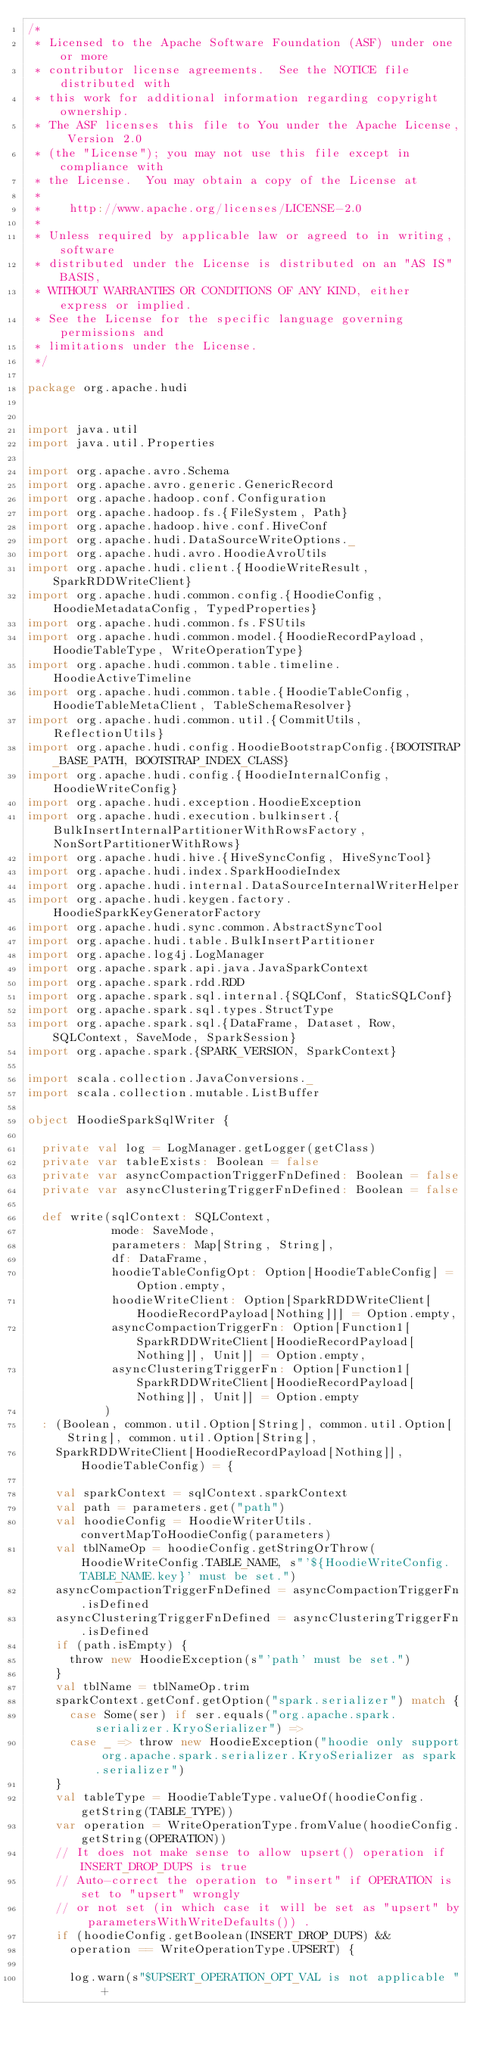<code> <loc_0><loc_0><loc_500><loc_500><_Scala_>/*
 * Licensed to the Apache Software Foundation (ASF) under one or more
 * contributor license agreements.  See the NOTICE file distributed with
 * this work for additional information regarding copyright ownership.
 * The ASF licenses this file to You under the Apache License, Version 2.0
 * (the "License"); you may not use this file except in compliance with
 * the License.  You may obtain a copy of the License at
 *
 *    http://www.apache.org/licenses/LICENSE-2.0
 *
 * Unless required by applicable law or agreed to in writing, software
 * distributed under the License is distributed on an "AS IS" BASIS,
 * WITHOUT WARRANTIES OR CONDITIONS OF ANY KIND, either express or implied.
 * See the License for the specific language governing permissions and
 * limitations under the License.
 */

package org.apache.hudi


import java.util
import java.util.Properties

import org.apache.avro.Schema
import org.apache.avro.generic.GenericRecord
import org.apache.hadoop.conf.Configuration
import org.apache.hadoop.fs.{FileSystem, Path}
import org.apache.hadoop.hive.conf.HiveConf
import org.apache.hudi.DataSourceWriteOptions._
import org.apache.hudi.avro.HoodieAvroUtils
import org.apache.hudi.client.{HoodieWriteResult, SparkRDDWriteClient}
import org.apache.hudi.common.config.{HoodieConfig, HoodieMetadataConfig, TypedProperties}
import org.apache.hudi.common.fs.FSUtils
import org.apache.hudi.common.model.{HoodieRecordPayload, HoodieTableType, WriteOperationType}
import org.apache.hudi.common.table.timeline.HoodieActiveTimeline
import org.apache.hudi.common.table.{HoodieTableConfig, HoodieTableMetaClient, TableSchemaResolver}
import org.apache.hudi.common.util.{CommitUtils, ReflectionUtils}
import org.apache.hudi.config.HoodieBootstrapConfig.{BOOTSTRAP_BASE_PATH, BOOTSTRAP_INDEX_CLASS}
import org.apache.hudi.config.{HoodieInternalConfig, HoodieWriteConfig}
import org.apache.hudi.exception.HoodieException
import org.apache.hudi.execution.bulkinsert.{BulkInsertInternalPartitionerWithRowsFactory, NonSortPartitionerWithRows}
import org.apache.hudi.hive.{HiveSyncConfig, HiveSyncTool}
import org.apache.hudi.index.SparkHoodieIndex
import org.apache.hudi.internal.DataSourceInternalWriterHelper
import org.apache.hudi.keygen.factory.HoodieSparkKeyGeneratorFactory
import org.apache.hudi.sync.common.AbstractSyncTool
import org.apache.hudi.table.BulkInsertPartitioner
import org.apache.log4j.LogManager
import org.apache.spark.api.java.JavaSparkContext
import org.apache.spark.rdd.RDD
import org.apache.spark.sql.internal.{SQLConf, StaticSQLConf}
import org.apache.spark.sql.types.StructType
import org.apache.spark.sql.{DataFrame, Dataset, Row, SQLContext, SaveMode, SparkSession}
import org.apache.spark.{SPARK_VERSION, SparkContext}

import scala.collection.JavaConversions._
import scala.collection.mutable.ListBuffer

object HoodieSparkSqlWriter {

  private val log = LogManager.getLogger(getClass)
  private var tableExists: Boolean = false
  private var asyncCompactionTriggerFnDefined: Boolean = false
  private var asyncClusteringTriggerFnDefined: Boolean = false

  def write(sqlContext: SQLContext,
            mode: SaveMode,
            parameters: Map[String, String],
            df: DataFrame,
            hoodieTableConfigOpt: Option[HoodieTableConfig] = Option.empty,
            hoodieWriteClient: Option[SparkRDDWriteClient[HoodieRecordPayload[Nothing]]] = Option.empty,
            asyncCompactionTriggerFn: Option[Function1[SparkRDDWriteClient[HoodieRecordPayload[Nothing]], Unit]] = Option.empty,
            asyncClusteringTriggerFn: Option[Function1[SparkRDDWriteClient[HoodieRecordPayload[Nothing]], Unit]] = Option.empty
           )
  : (Boolean, common.util.Option[String], common.util.Option[String], common.util.Option[String],
    SparkRDDWriteClient[HoodieRecordPayload[Nothing]], HoodieTableConfig) = {

    val sparkContext = sqlContext.sparkContext
    val path = parameters.get("path")
    val hoodieConfig = HoodieWriterUtils.convertMapToHoodieConfig(parameters)
    val tblNameOp = hoodieConfig.getStringOrThrow(HoodieWriteConfig.TABLE_NAME, s"'${HoodieWriteConfig.TABLE_NAME.key}' must be set.")
    asyncCompactionTriggerFnDefined = asyncCompactionTriggerFn.isDefined
    asyncClusteringTriggerFnDefined = asyncClusteringTriggerFn.isDefined
    if (path.isEmpty) {
      throw new HoodieException(s"'path' must be set.")
    }
    val tblName = tblNameOp.trim
    sparkContext.getConf.getOption("spark.serializer") match {
      case Some(ser) if ser.equals("org.apache.spark.serializer.KryoSerializer") =>
      case _ => throw new HoodieException("hoodie only support org.apache.spark.serializer.KryoSerializer as spark.serializer")
    }
    val tableType = HoodieTableType.valueOf(hoodieConfig.getString(TABLE_TYPE))
    var operation = WriteOperationType.fromValue(hoodieConfig.getString(OPERATION))
    // It does not make sense to allow upsert() operation if INSERT_DROP_DUPS is true
    // Auto-correct the operation to "insert" if OPERATION is set to "upsert" wrongly
    // or not set (in which case it will be set as "upsert" by parametersWithWriteDefaults()) .
    if (hoodieConfig.getBoolean(INSERT_DROP_DUPS) &&
      operation == WriteOperationType.UPSERT) {

      log.warn(s"$UPSERT_OPERATION_OPT_VAL is not applicable " +</code> 